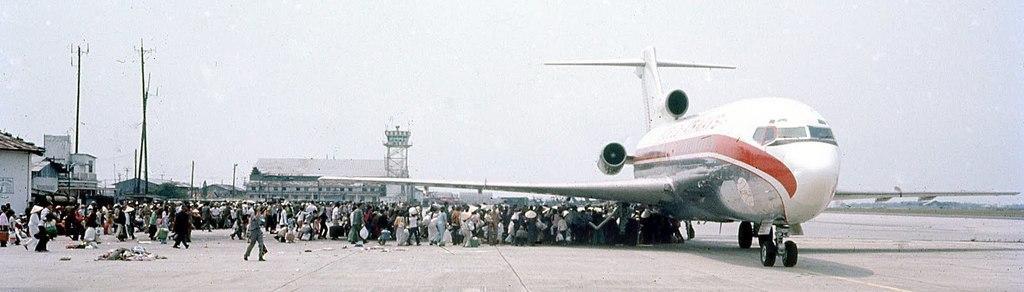In one or two sentences, can you explain what this image depicts? In the image we can see there is an aeroplane parked on the runway and there are lot of people standing on the runway road. Behind there are buildings and there are iron poles on the road. There is a clear sky. 